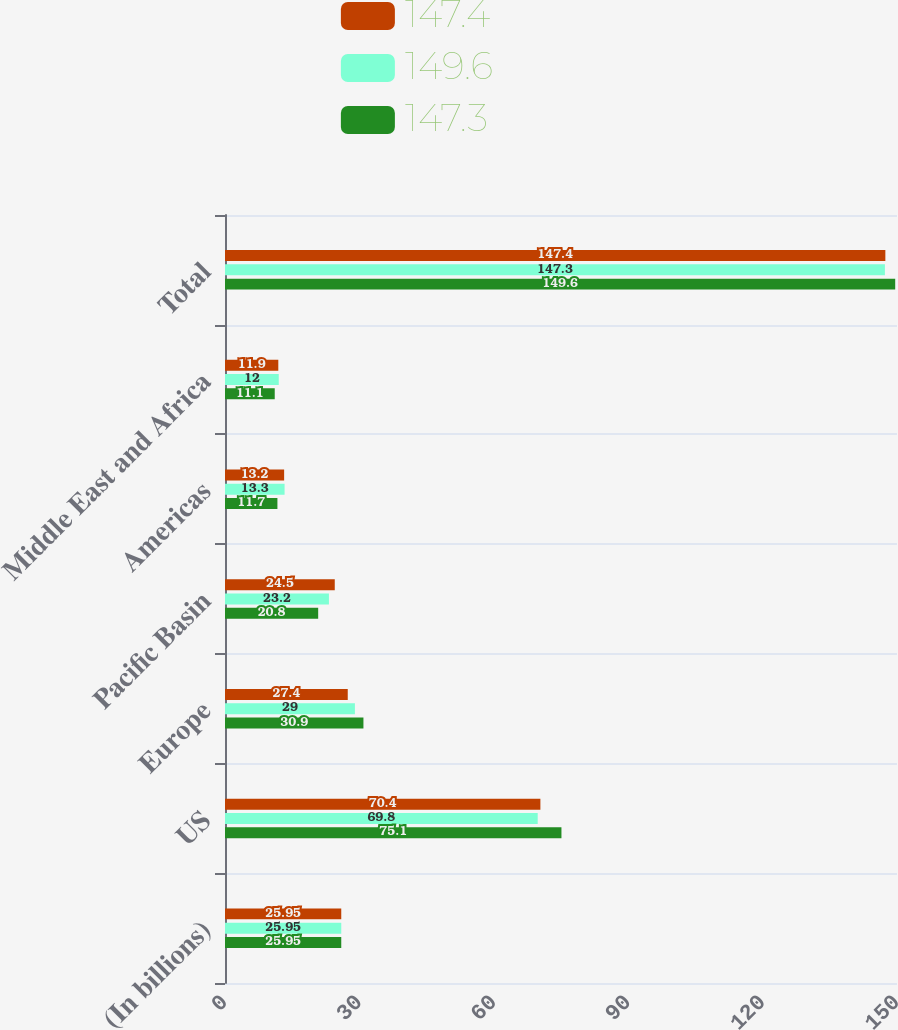Convert chart to OTSL. <chart><loc_0><loc_0><loc_500><loc_500><stacked_bar_chart><ecel><fcel>(In billions)<fcel>US<fcel>Europe<fcel>Pacific Basin<fcel>Americas<fcel>Middle East and Africa<fcel>Total<nl><fcel>147.4<fcel>25.95<fcel>70.4<fcel>27.4<fcel>24.5<fcel>13.2<fcel>11.9<fcel>147.4<nl><fcel>149.6<fcel>25.95<fcel>69.8<fcel>29<fcel>23.2<fcel>13.3<fcel>12<fcel>147.3<nl><fcel>147.3<fcel>25.95<fcel>75.1<fcel>30.9<fcel>20.8<fcel>11.7<fcel>11.1<fcel>149.6<nl></chart> 